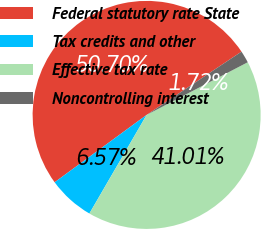Convert chart to OTSL. <chart><loc_0><loc_0><loc_500><loc_500><pie_chart><fcel>Federal statutory rate State<fcel>Tax credits and other<fcel>Effective tax rate<fcel>Noncontrolling interest<nl><fcel>50.7%<fcel>6.57%<fcel>41.01%<fcel>1.72%<nl></chart> 